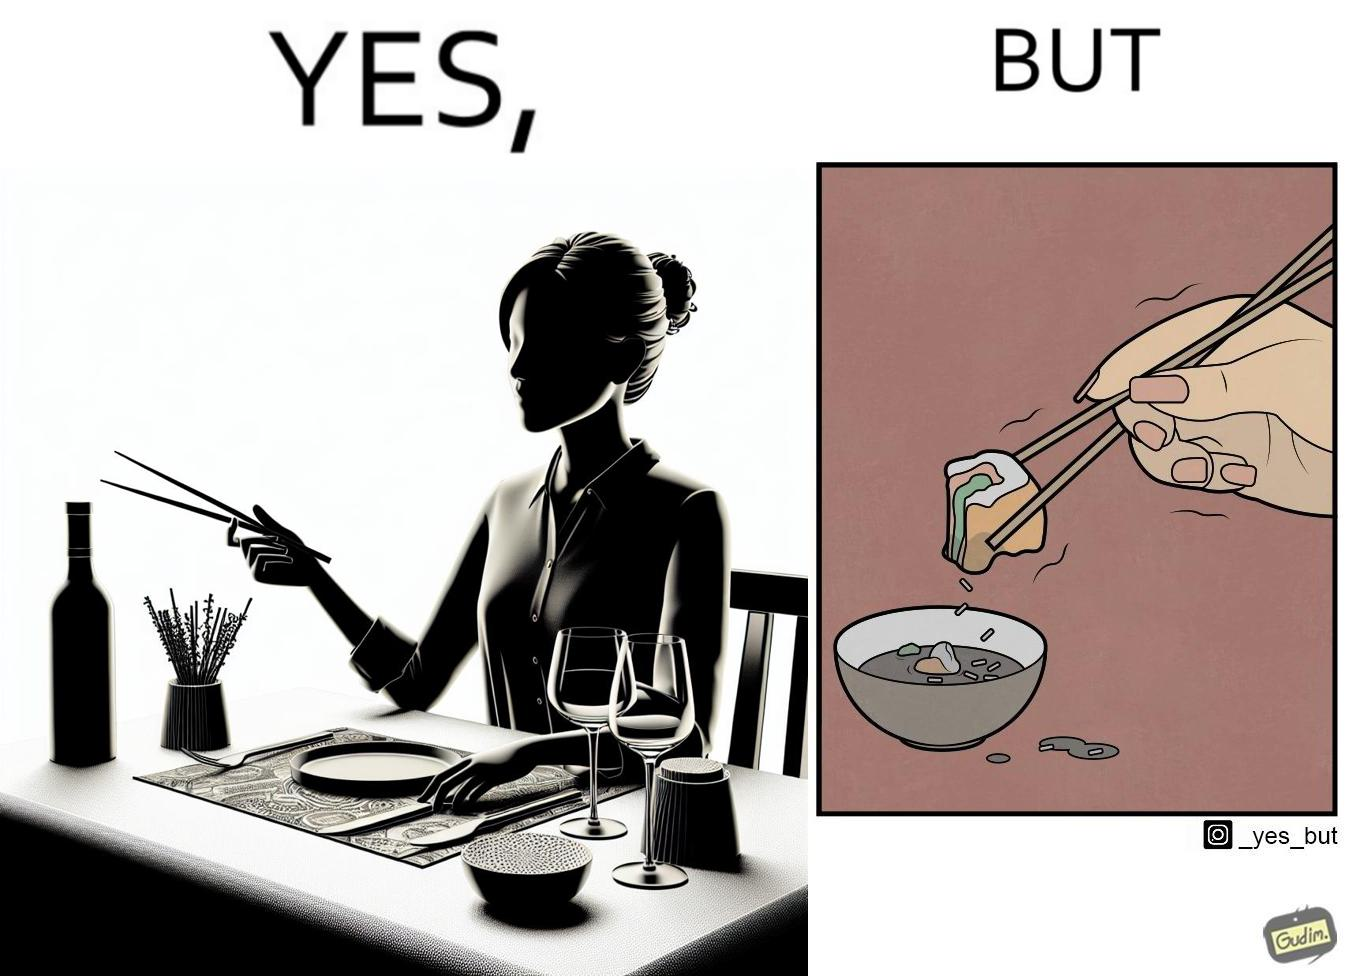What makes this image funny or satirical? The image is satirical because even thought the woman is not able to eat food with chopstick properly, she chooses it over fork and knife to look sophisticaed. 